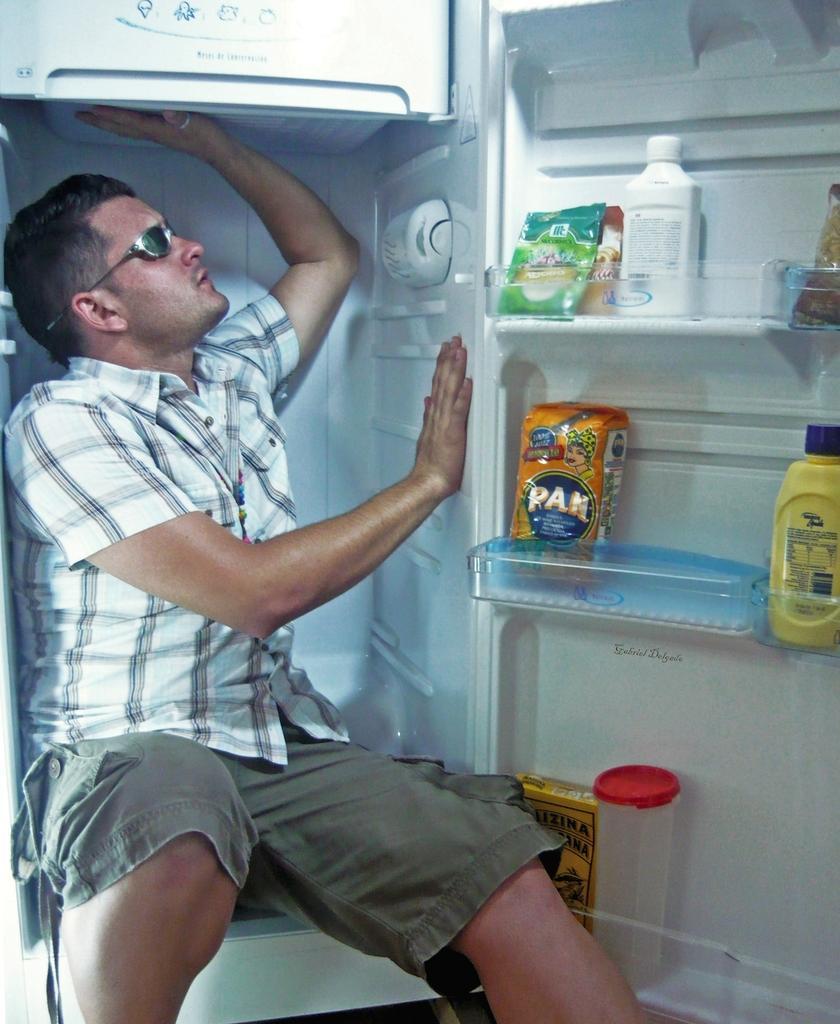Can you describe this image briefly? There is a person wearing goggles is sitting inside the fridge. On the door of the fridge there are racks. On that there are bottles and packets. 